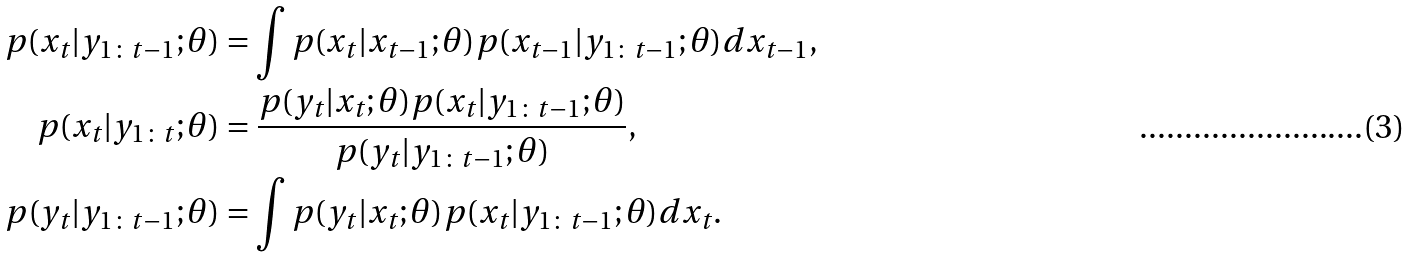<formula> <loc_0><loc_0><loc_500><loc_500>p ( x _ { t } | y _ { 1 \colon t - 1 } ; \theta ) & = \int p ( x _ { t } | x _ { t - 1 } ; \theta ) p ( x _ { t - 1 } | y _ { 1 \colon t - 1 } ; \theta ) d x _ { t - 1 } , \\ p ( x _ { t } | y _ { 1 \colon t } ; \theta ) & = \frac { p ( y _ { t } | x _ { t } ; \theta ) p ( x _ { t } | y _ { 1 \colon t - 1 } ; \theta ) } { p ( y _ { t } | y _ { 1 \colon t - 1 } ; \theta ) } , \\ p ( y _ { t } | y _ { 1 \colon t - 1 } ; \theta ) & = \int p ( y _ { t } | x _ { t } ; \theta ) p ( x _ { t } | y _ { 1 \colon t - 1 } ; \theta ) d x _ { t } .</formula> 